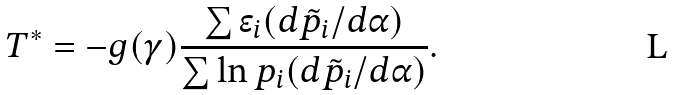Convert formula to latex. <formula><loc_0><loc_0><loc_500><loc_500>T ^ { * } = - g ( \gamma ) \frac { \sum \epsilon _ { i } ( d \tilde { p } _ { i } / d \alpha ) } { \sum \ln { p _ { i } } ( d \tilde { p } _ { i } / d \alpha ) } .</formula> 